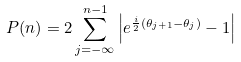Convert formula to latex. <formula><loc_0><loc_0><loc_500><loc_500>P ( n ) = 2 \sum _ { j = - \infty } ^ { n - 1 } \left | e ^ { \frac { i } { 2 } ( \theta _ { j + 1 } - \theta _ { j } ) } - 1 \right |</formula> 